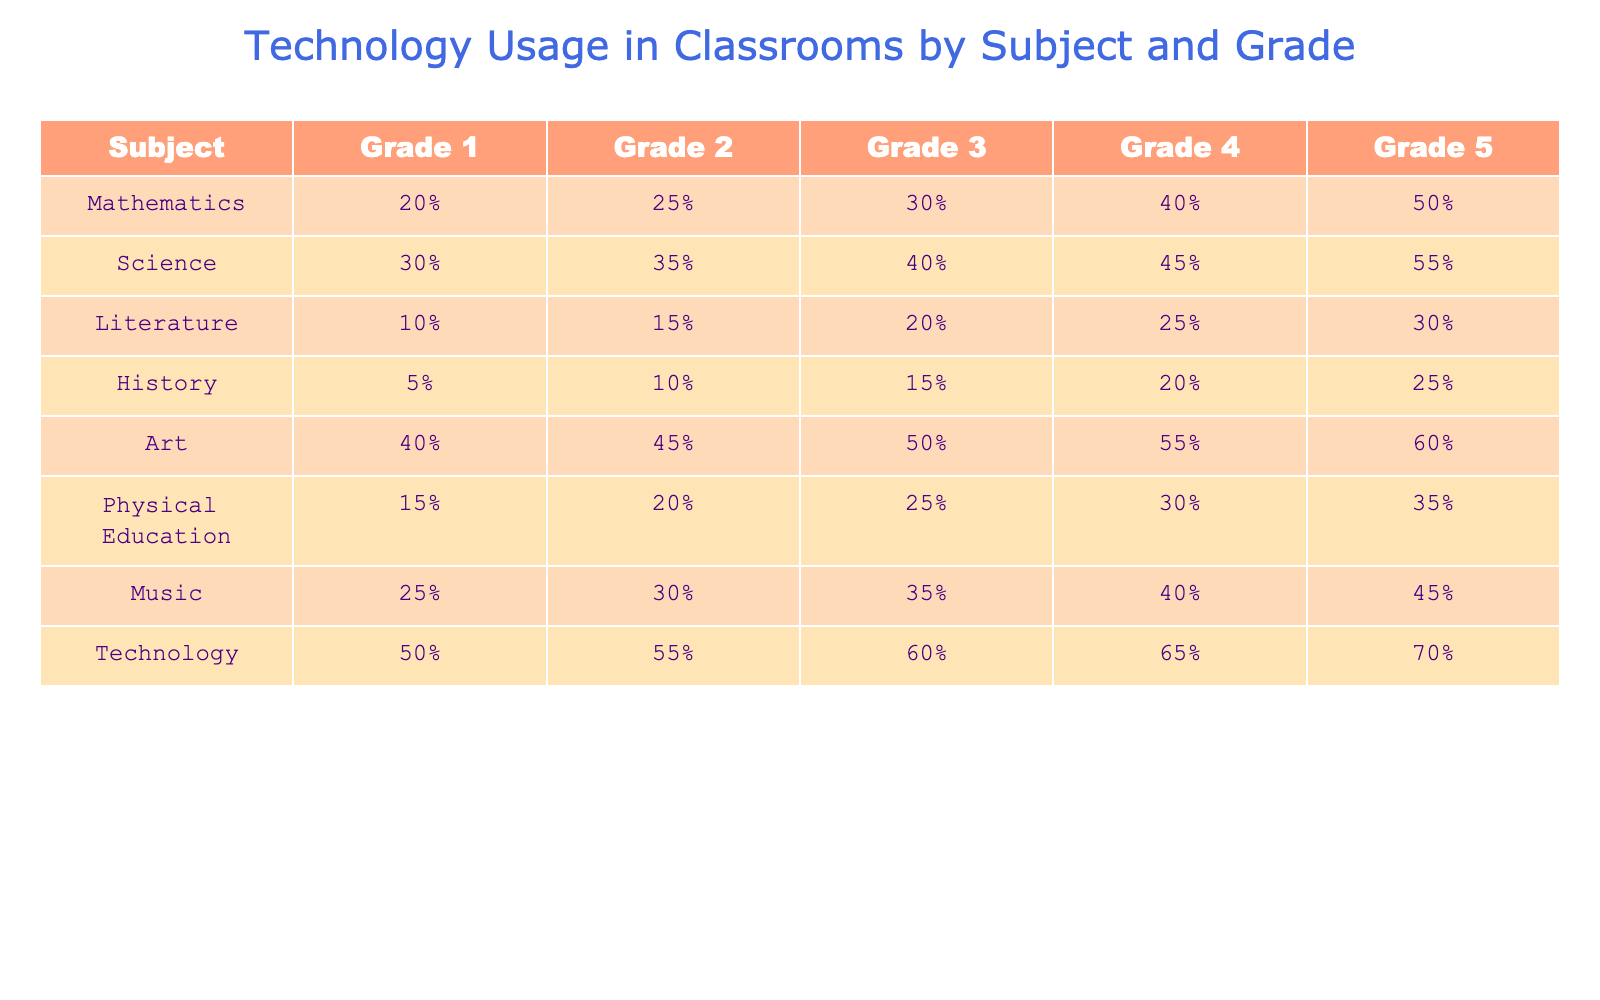What subject has the highest technology usage in Grade 5? In the table, I can look at the last column corresponding to Grade 5. The percentages listed for each subject indicate technology usage. The subject with the highest percentage in Grade 5 is Technology, which has 70%.
Answer: Technology What is the percentage increase in technology usage from Grade 1 to Grade 4? I look at the technology usage for Grade 1, which is 50%, and for Grade 4, which is 65%. The increase is calculated as (65 - 50) = 15%. Therefore, the percentage increase relative to the Grade 1 usage is (15/50) * 100 = 30%.
Answer: 30% Is the technology usage in Literature higher than in History for all grades? To answer this, I need to compare the percentages for Literature and History across all grades. For Grade 1, Literature is 10% and History is 5% (true), Grade 2 has Literature at 15% and History at 10% (true), Grade 3 is 20% vs 15% (true), Grade 4 is 25% vs 20% (true), and Grade 5 is 30% vs 25% (true). Since Literature is always higher, the answer is yes.
Answer: Yes What is the average technology usage across all grades for Mathematics? I gather the technology usage percentages for Mathematics, which are 20%, 25%, 30%, 40%, and 50%. I then sum these values: 20 + 25 + 30 + 40 + 50 = 165. There are 5 grades, so the average is 165/5 = 33%.
Answer: 33% How much more technology usage does Science have compared to Physical Education in Grade 3? I look at the technology usage for Science in Grade 3, which is 40%, and for Physical Education, which is 25%. The difference is 40% - 25% = 15%.
Answer: 15% 